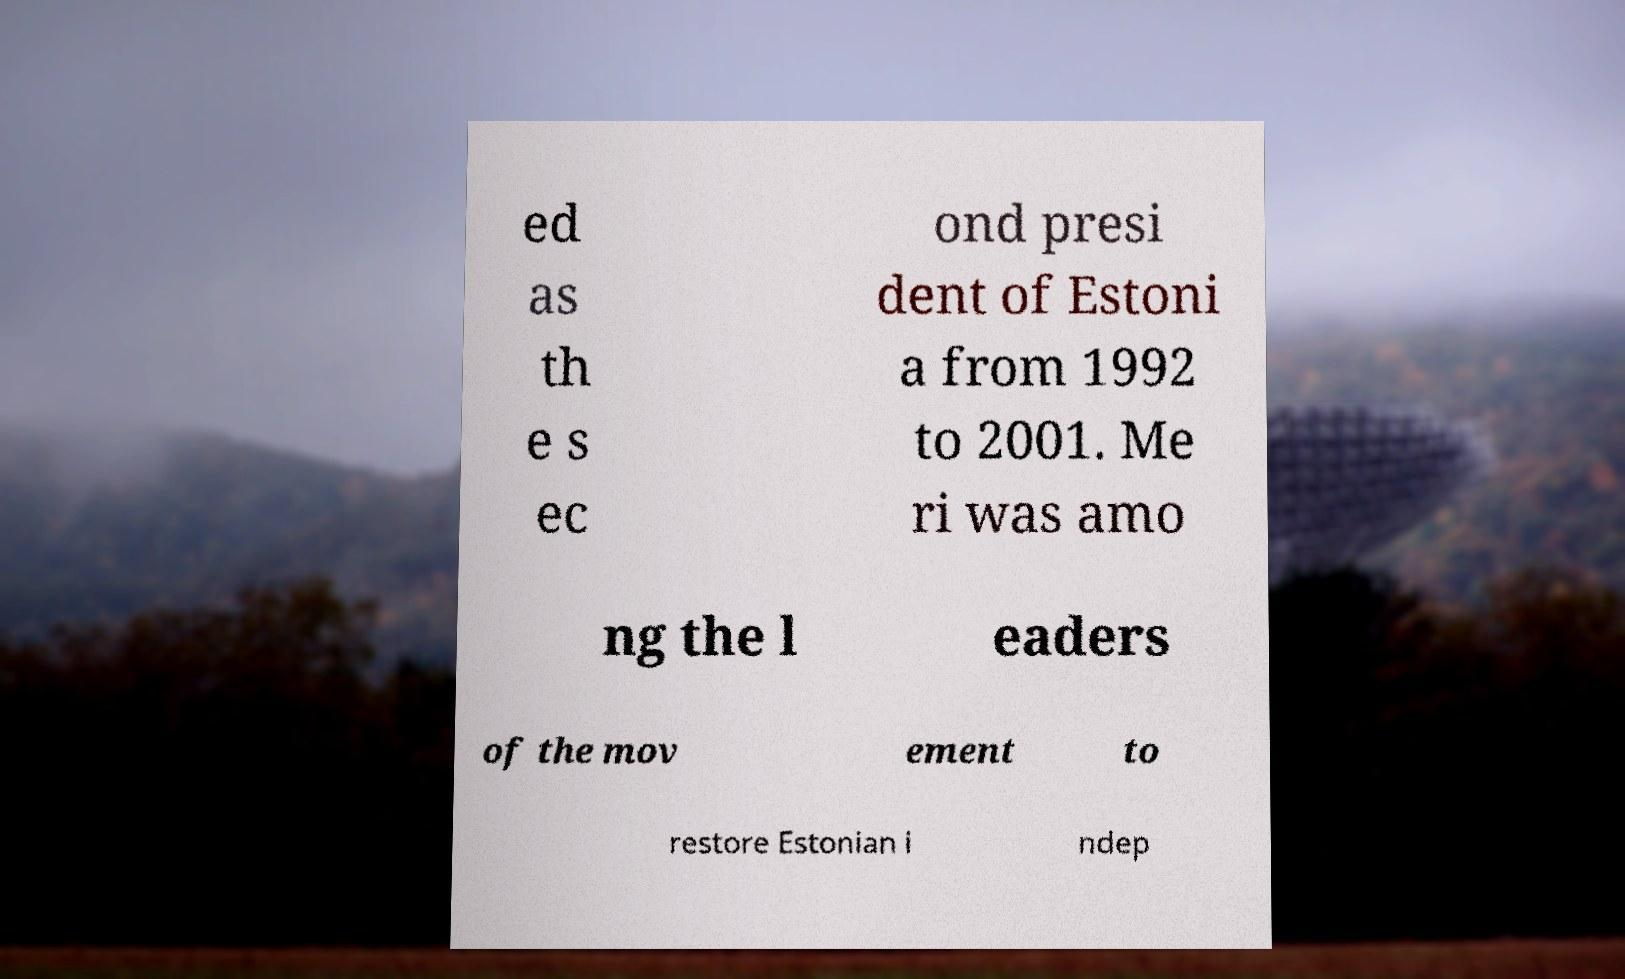Could you assist in decoding the text presented in this image and type it out clearly? ed as th e s ec ond presi dent of Estoni a from 1992 to 2001. Me ri was amo ng the l eaders of the mov ement to restore Estonian i ndep 